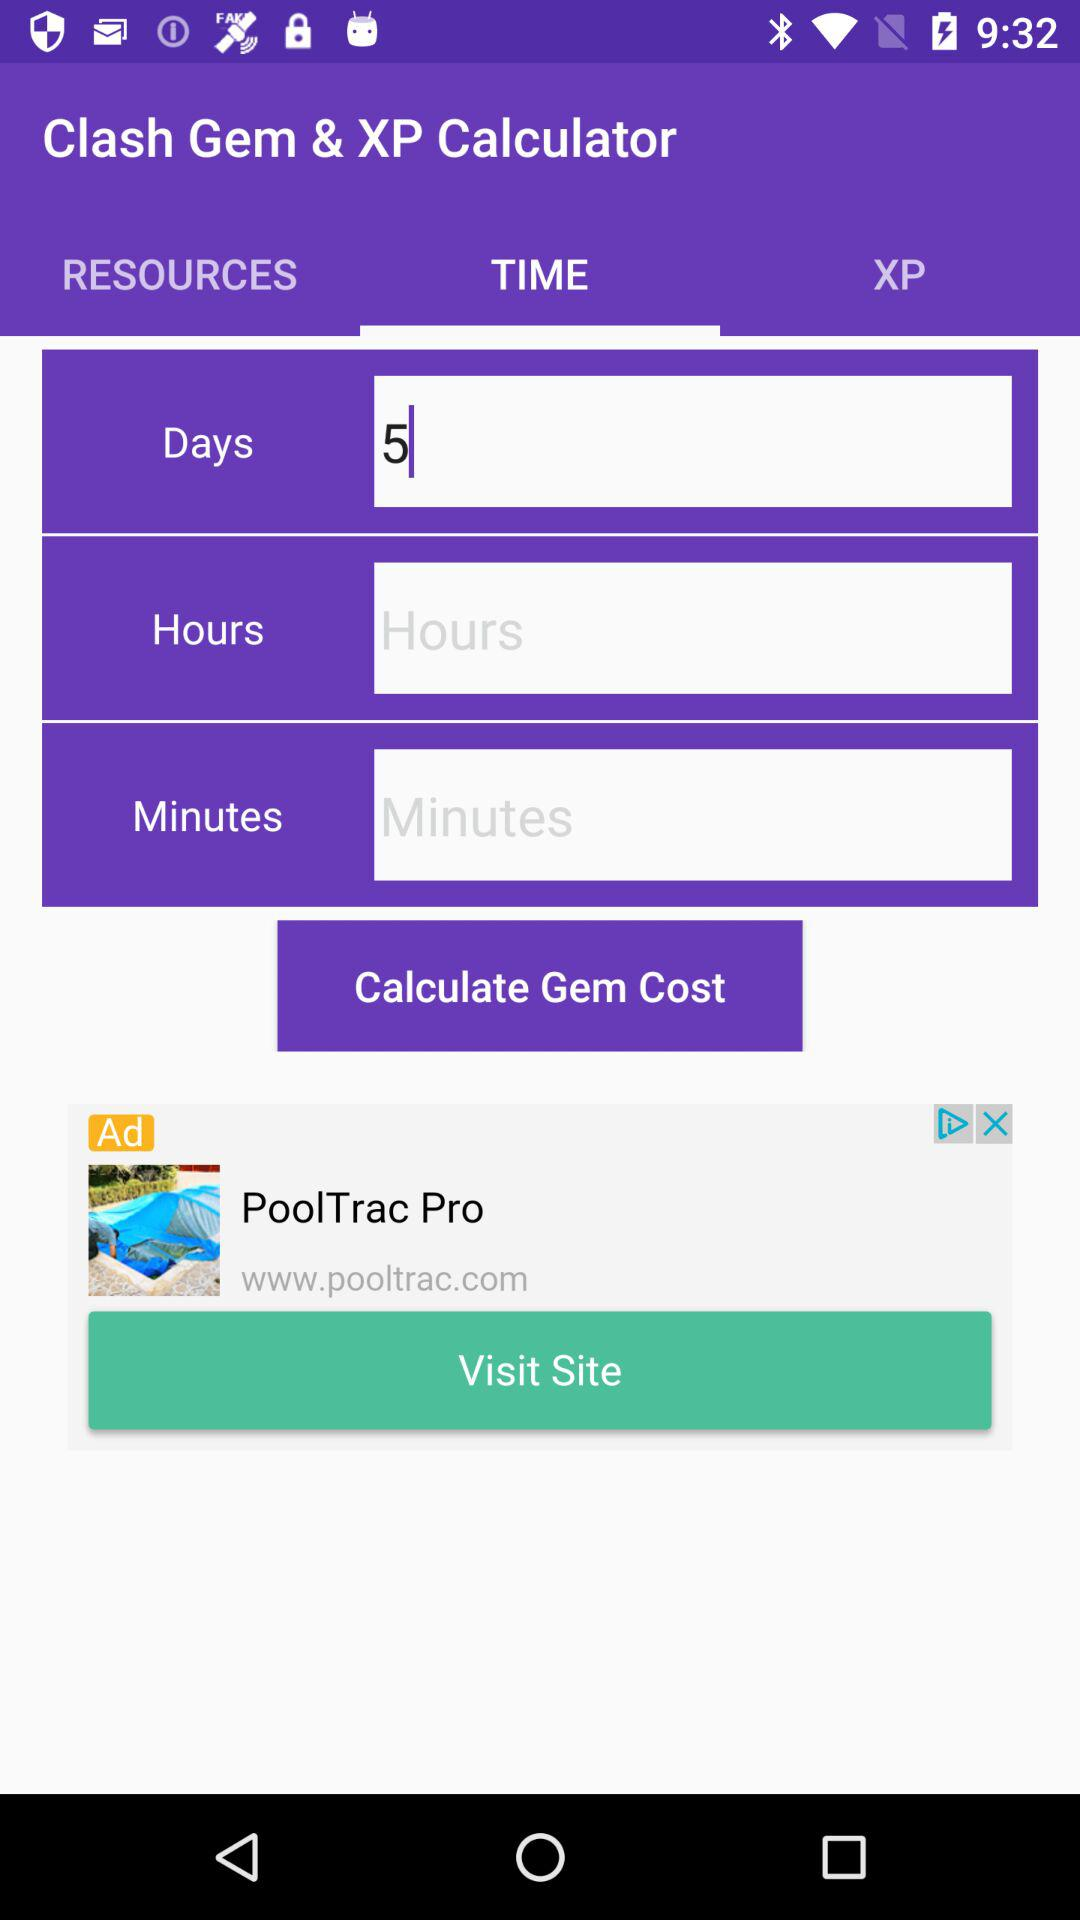Which tab is selected? The selected tab is "TIME". 